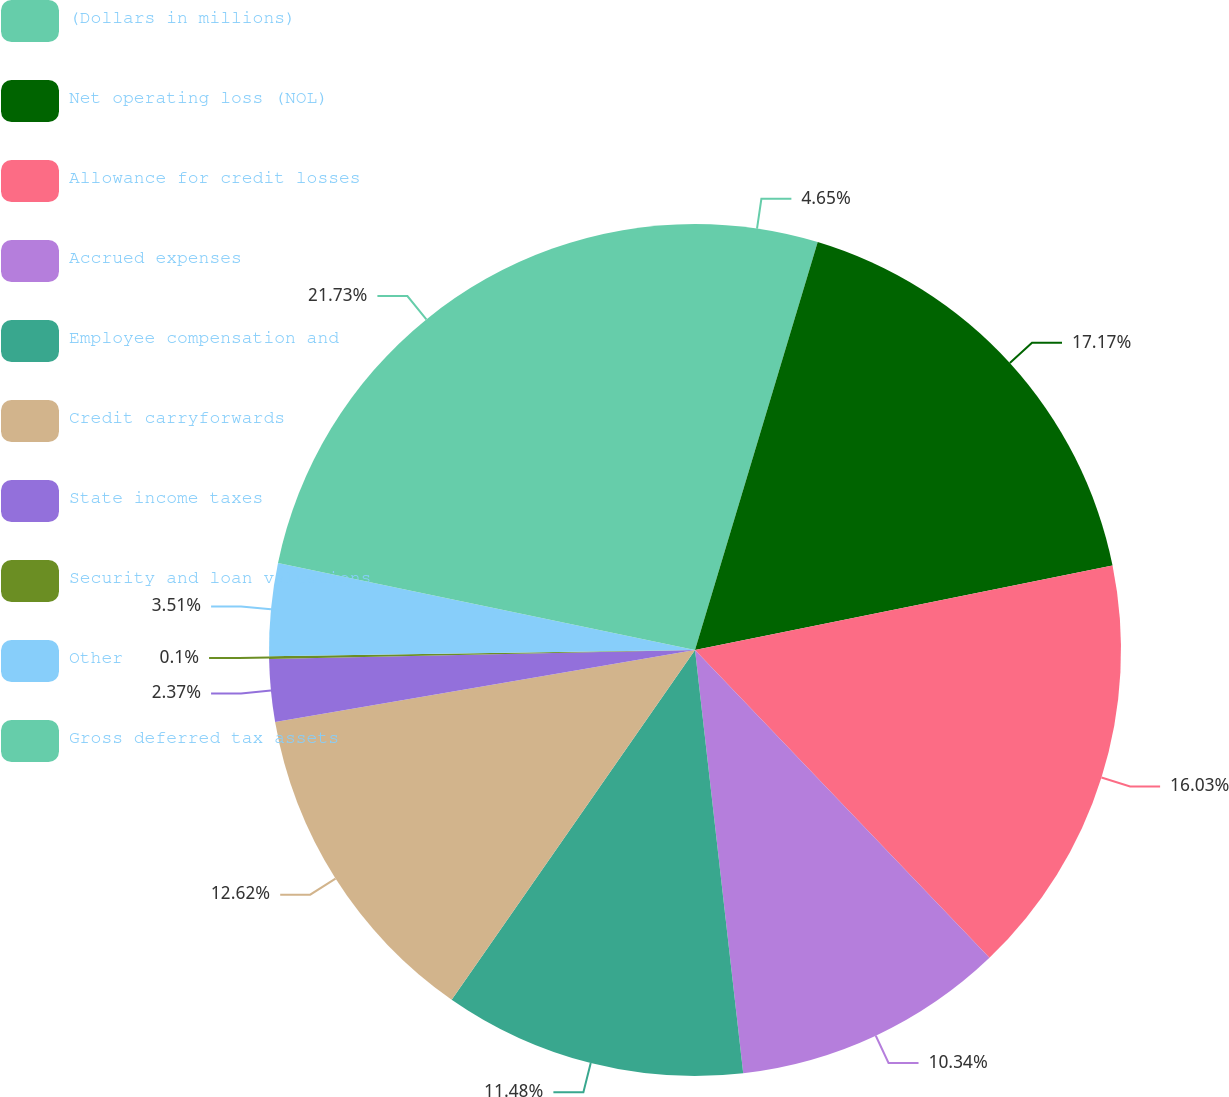Convert chart to OTSL. <chart><loc_0><loc_0><loc_500><loc_500><pie_chart><fcel>(Dollars in millions)<fcel>Net operating loss (NOL)<fcel>Allowance for credit losses<fcel>Accrued expenses<fcel>Employee compensation and<fcel>Credit carryforwards<fcel>State income taxes<fcel>Security and loan valuations<fcel>Other<fcel>Gross deferred tax assets<nl><fcel>4.65%<fcel>17.17%<fcel>16.03%<fcel>10.34%<fcel>11.48%<fcel>12.62%<fcel>2.37%<fcel>0.1%<fcel>3.51%<fcel>21.72%<nl></chart> 